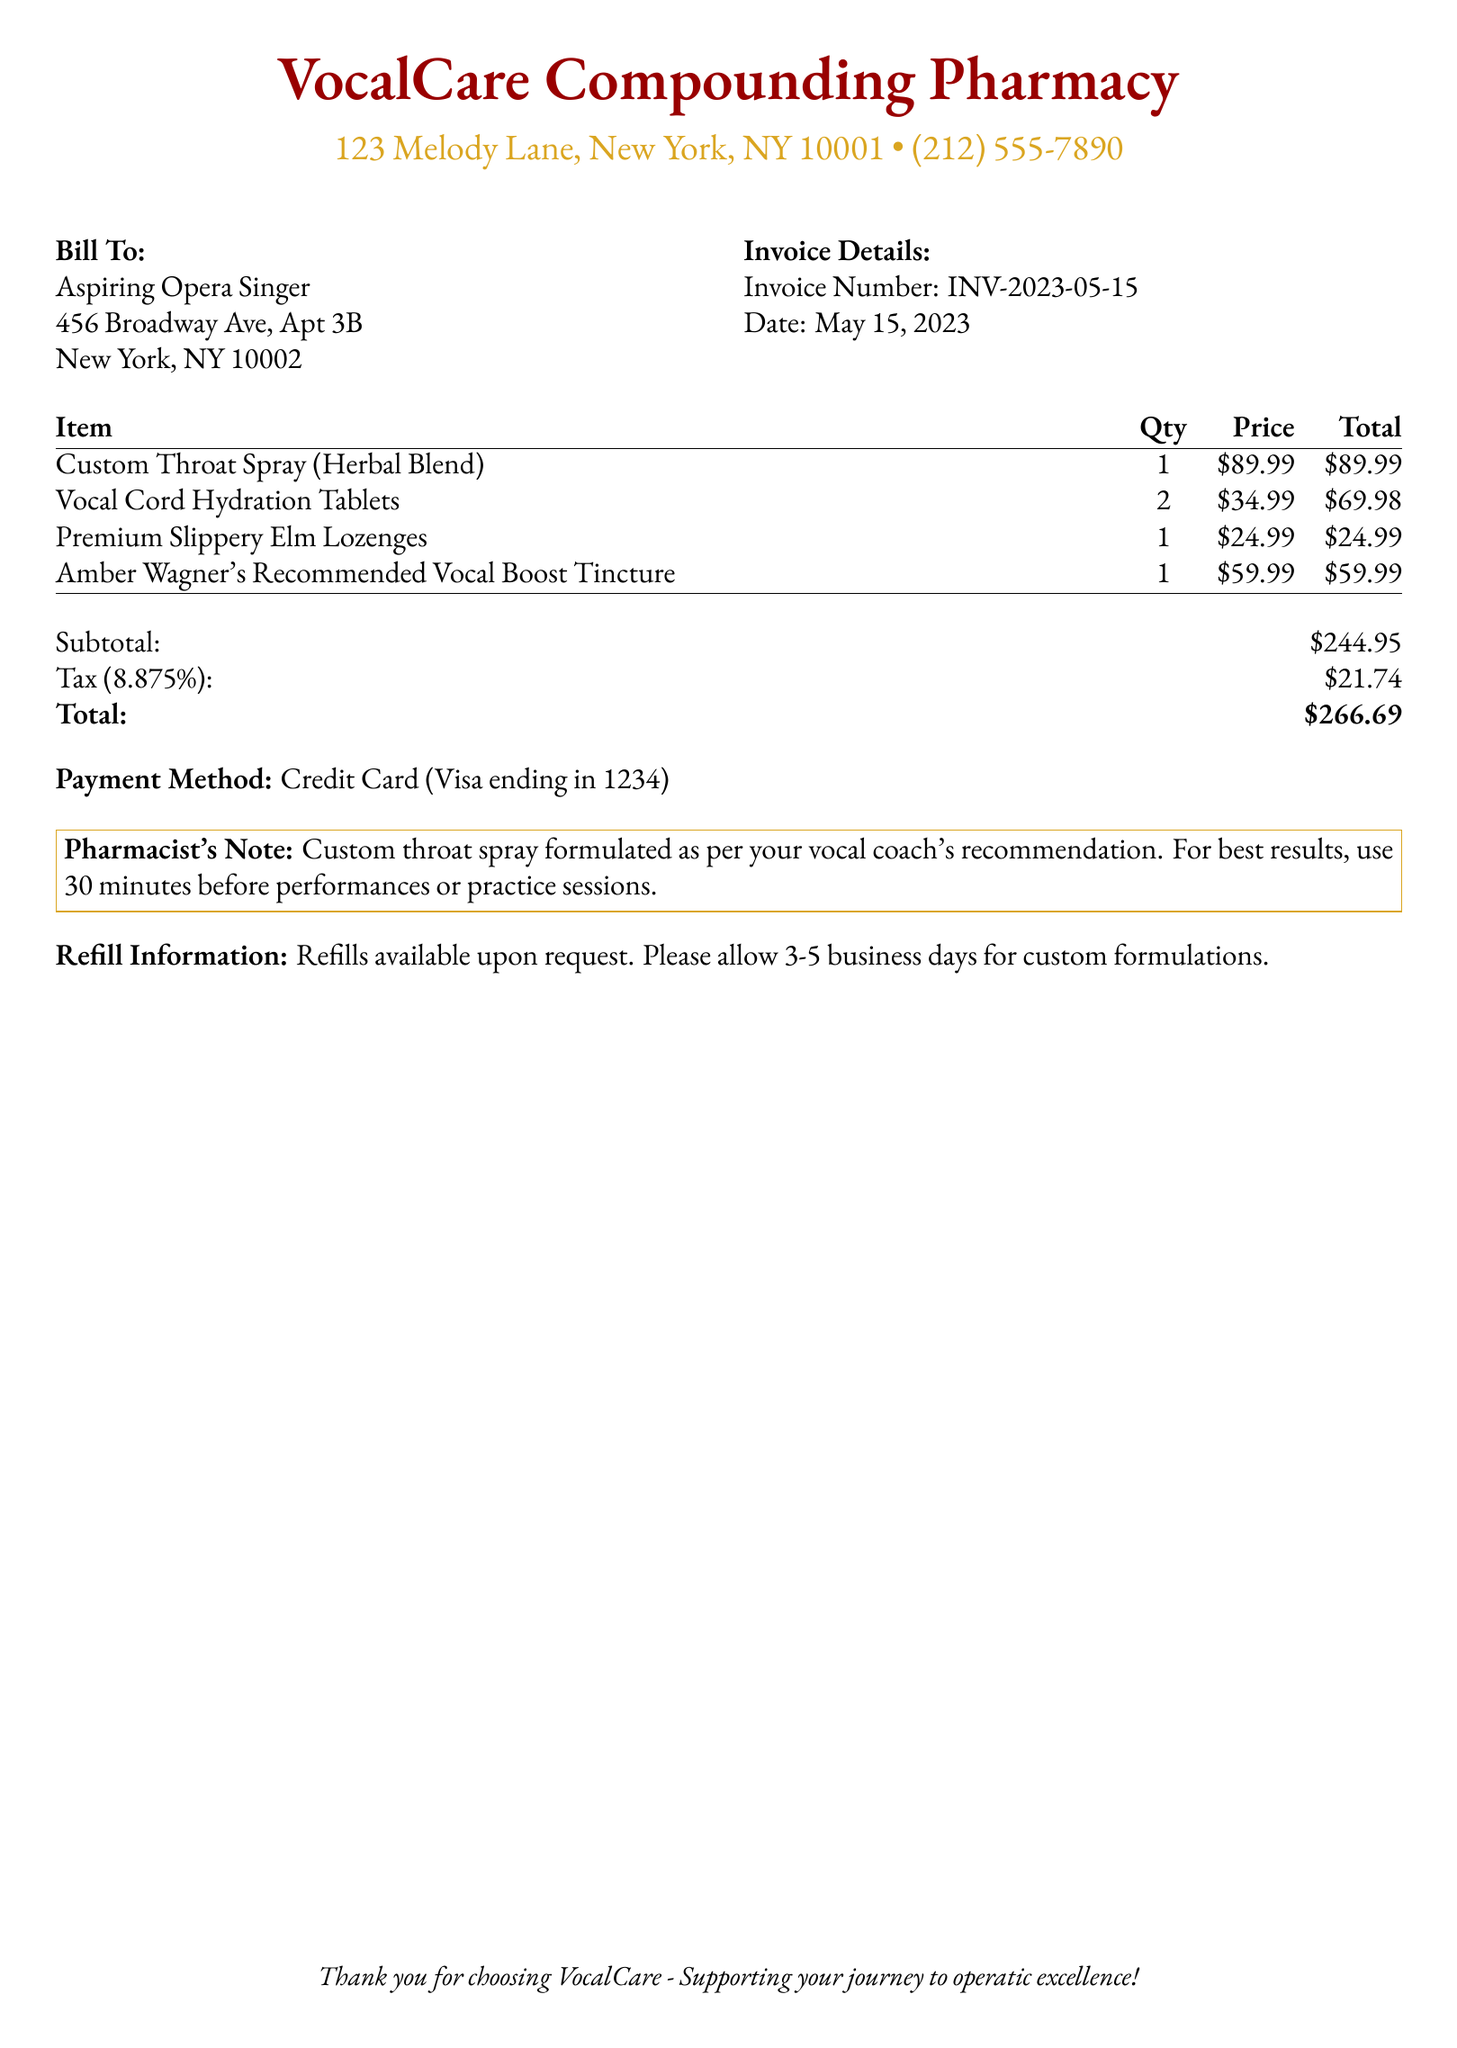What is the invoice number? The invoice number is a unique identifier for the bill, listed in the invoice details section.
Answer: INV-2023-05-15 What is the date of the invoice? The date indicates when the invoice was issued, found in the invoice details.
Answer: May 15, 2023 How many Vocal Cord Hydration Tablets were ordered? This quantity is specified next to the item in the bill, indicating how many were purchased.
Answer: 2 What is the subtotal amount? The subtotal is the sum of all items before tax, shown at the bottom of the itemized list.
Answer: $244.95 What percentage is the tax on this invoice? The tax percentage indicates the rate applied to the subtotal, mentioned in the summary section.
Answer: 8.875% What is the total amount billed? The total is the final amount owed, including tax, provided in the summary.
Answer: $266.69 What is the payment method used? This specifies how the invoice will be settled, indicated in the payment method section.
Answer: Credit Card (Visa ending in 1234) What is the recommended use for the custom throat spray? The recommendation suggests the best time to use the product, noted in the pharmacist's note.
Answer: 30 minutes before performances or practice sessions Are refills available? Refills information indicates whether customers can get more of the products when needed, mentioned in the document.
Answer: Yes 